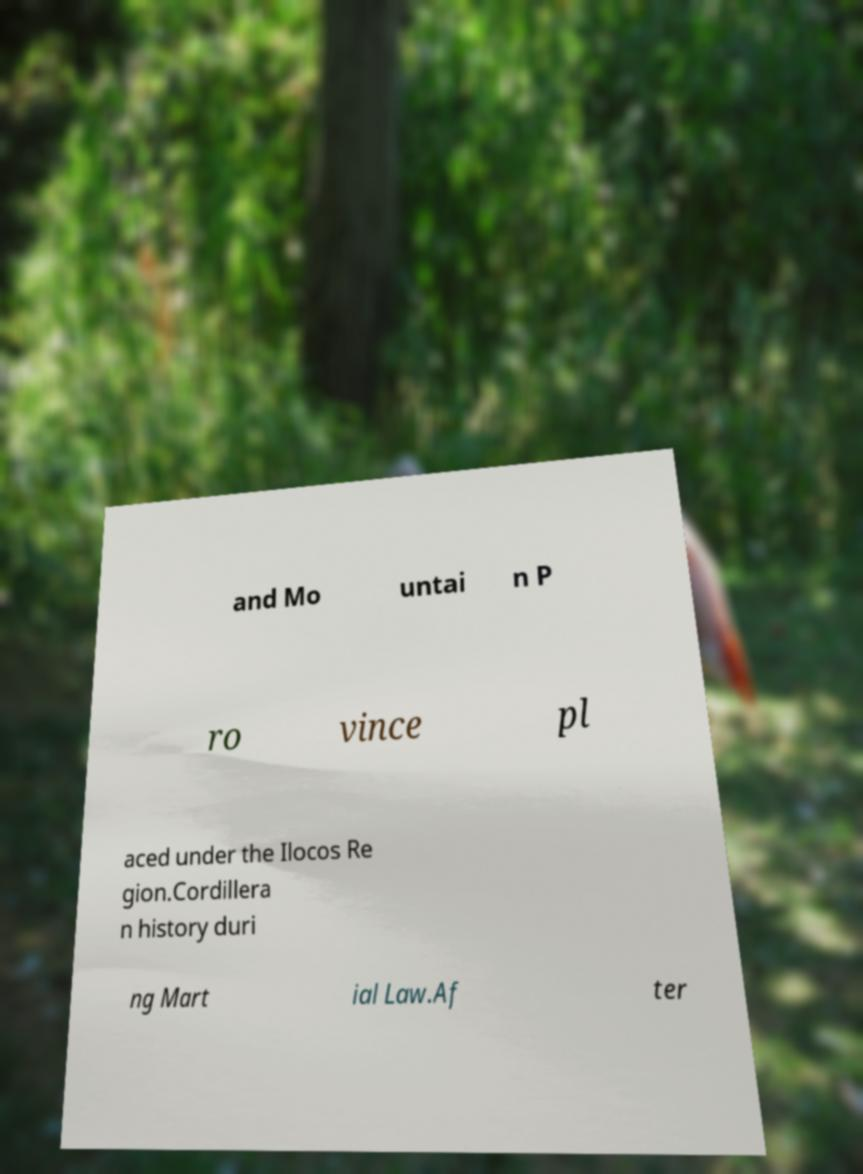Please read and relay the text visible in this image. What does it say? and Mo untai n P ro vince pl aced under the Ilocos Re gion.Cordillera n history duri ng Mart ial Law.Af ter 